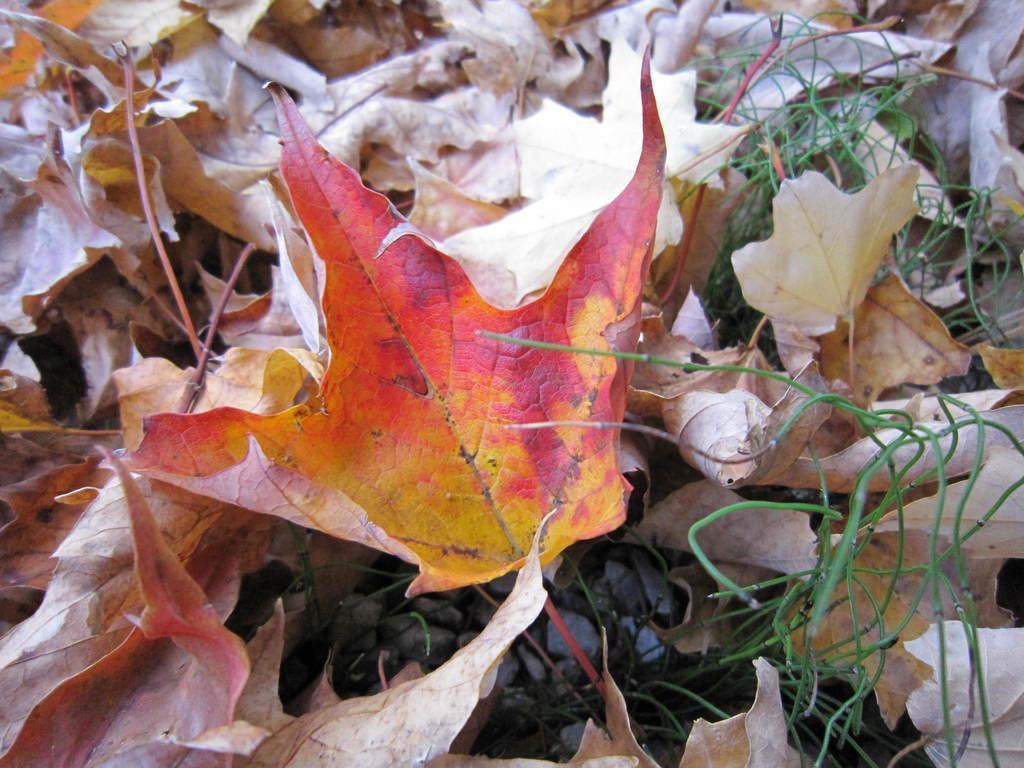Please provide a concise description of this image. In this image we can see some leaves, stones and the grass. 